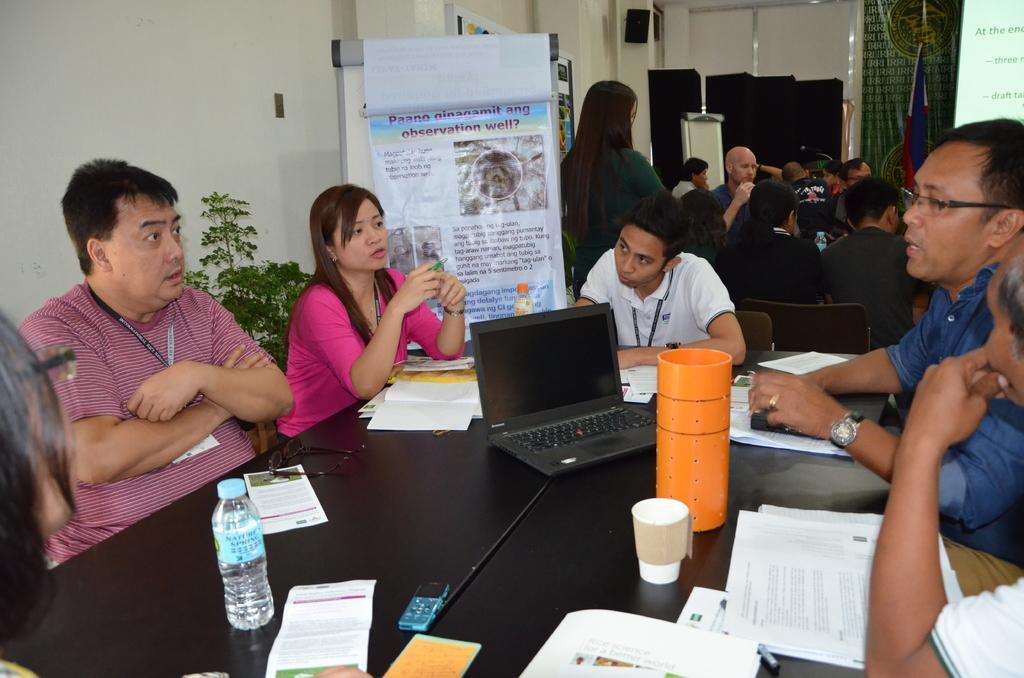How would you summarize this image in a sentence or two? In this image there are a few people sitting in front of the table. On the table there is a laptop, papers, bottle, glass, books and a few other objects. On the left side of the image there is a plant, behind the plant there is a wall and a banner, beside the banner there is are few other people. In the background there are few objects and a screen. 